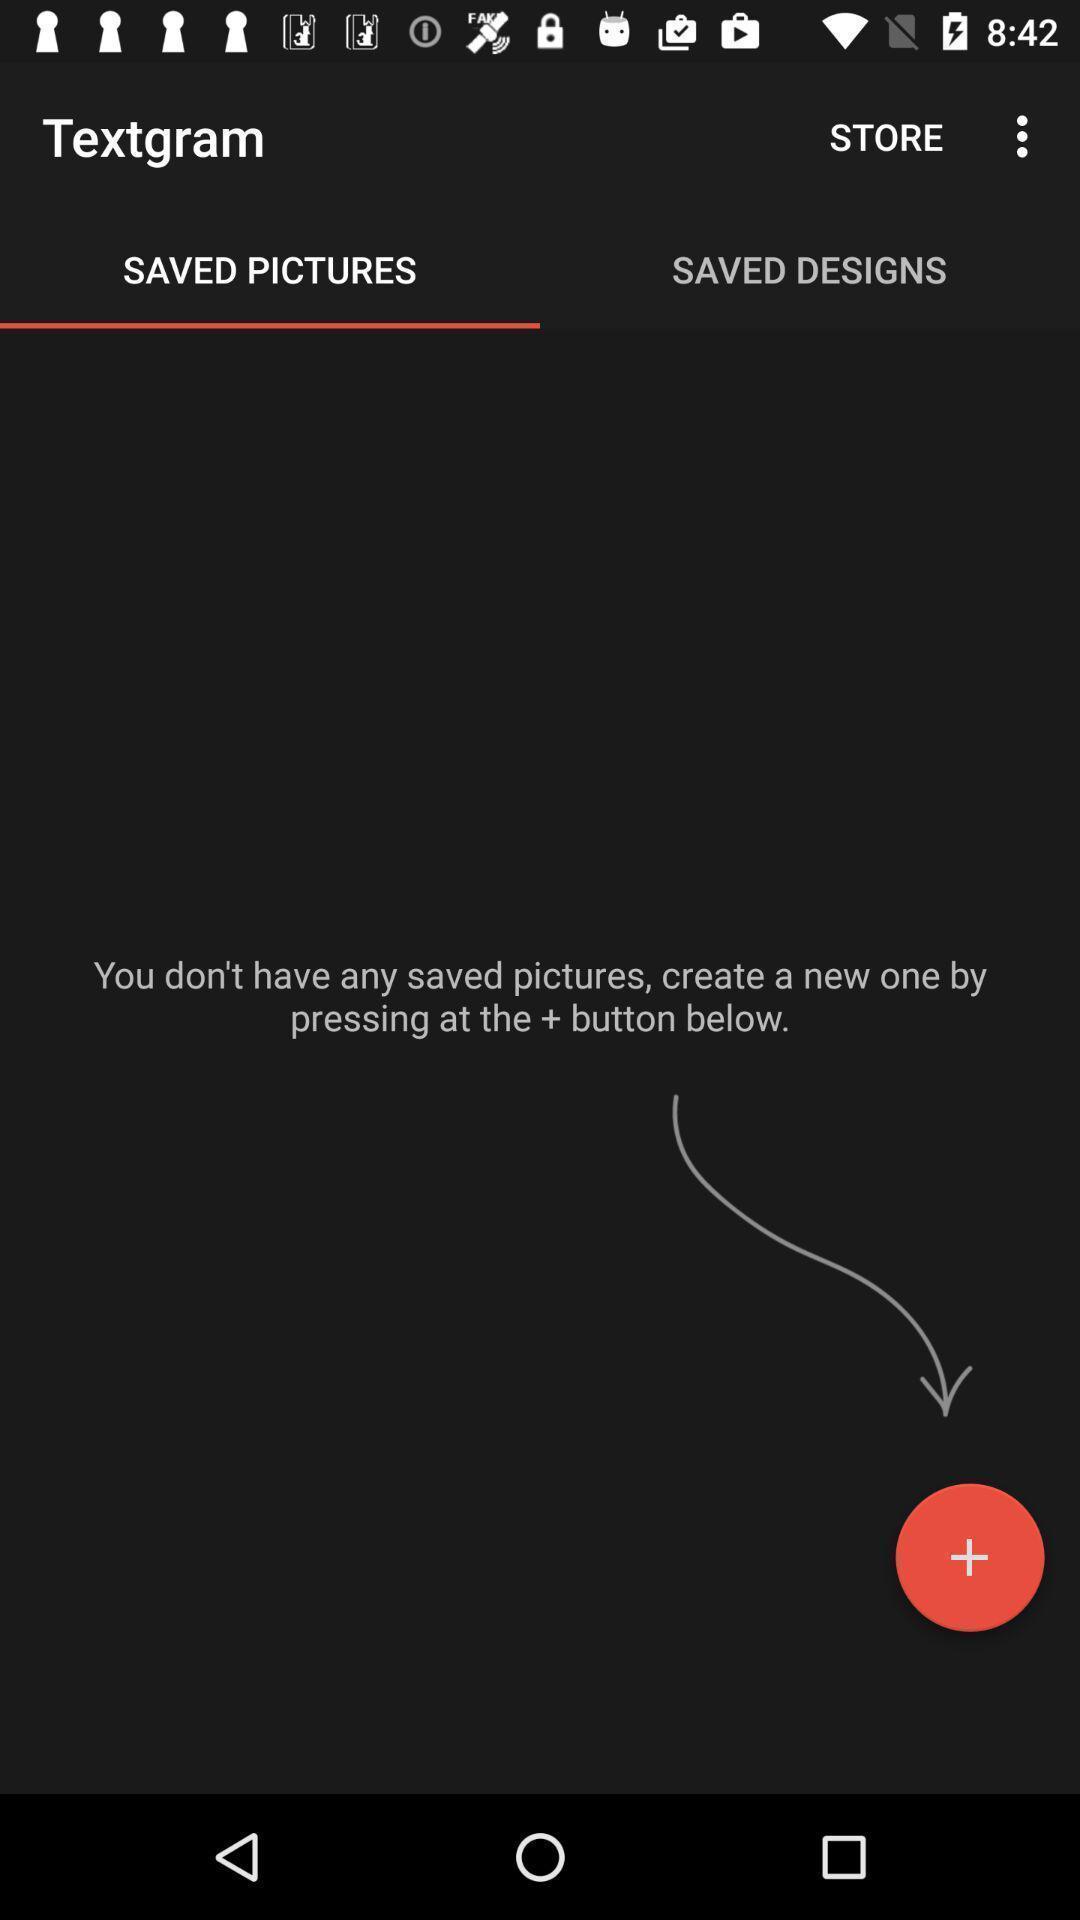Explain the elements present in this screenshot. Saved pictures page. 